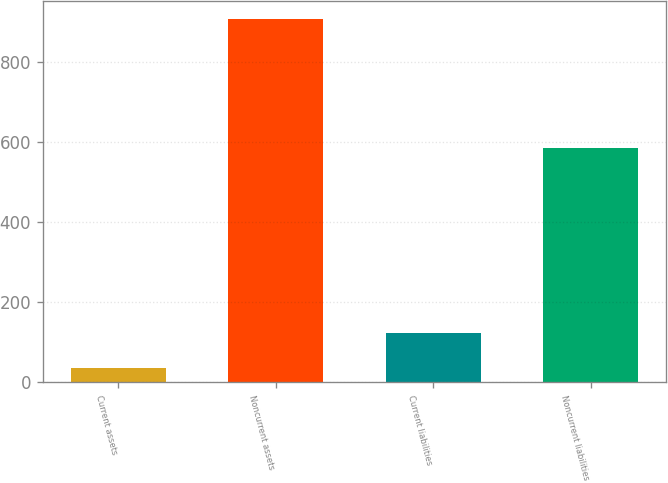Convert chart to OTSL. <chart><loc_0><loc_0><loc_500><loc_500><bar_chart><fcel>Current assets<fcel>Noncurrent assets<fcel>Current liabilities<fcel>Noncurrent liabilities<nl><fcel>36<fcel>908<fcel>123.2<fcel>585<nl></chart> 